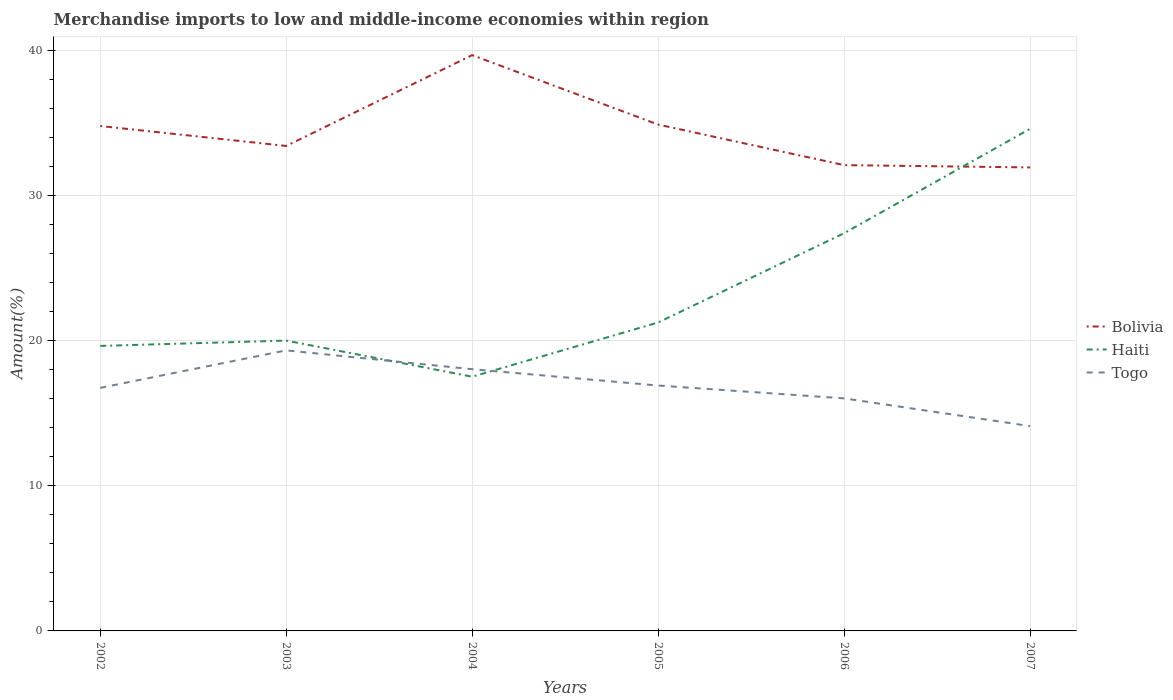How many different coloured lines are there?
Make the answer very short. 3. Across all years, what is the maximum percentage of amount earned from merchandise imports in Bolivia?
Your answer should be very brief. 31.94. In which year was the percentage of amount earned from merchandise imports in Togo maximum?
Your answer should be very brief. 2007. What is the total percentage of amount earned from merchandise imports in Haiti in the graph?
Offer a very short reply. -6.15. What is the difference between the highest and the second highest percentage of amount earned from merchandise imports in Togo?
Offer a terse response. 5.22. How many lines are there?
Your answer should be very brief. 3. Does the graph contain any zero values?
Offer a very short reply. No. Does the graph contain grids?
Give a very brief answer. Yes. Where does the legend appear in the graph?
Provide a succinct answer. Center right. How many legend labels are there?
Keep it short and to the point. 3. What is the title of the graph?
Offer a terse response. Merchandise imports to low and middle-income economies within region. Does "Croatia" appear as one of the legend labels in the graph?
Ensure brevity in your answer.  No. What is the label or title of the Y-axis?
Your answer should be very brief. Amount(%). What is the Amount(%) of Bolivia in 2002?
Ensure brevity in your answer.  34.79. What is the Amount(%) in Haiti in 2002?
Your answer should be compact. 19.64. What is the Amount(%) in Togo in 2002?
Make the answer very short. 16.75. What is the Amount(%) in Bolivia in 2003?
Offer a terse response. 33.42. What is the Amount(%) in Haiti in 2003?
Offer a very short reply. 20. What is the Amount(%) of Togo in 2003?
Offer a very short reply. 19.33. What is the Amount(%) of Bolivia in 2004?
Your response must be concise. 39.67. What is the Amount(%) of Haiti in 2004?
Give a very brief answer. 17.52. What is the Amount(%) of Togo in 2004?
Ensure brevity in your answer.  18.03. What is the Amount(%) of Bolivia in 2005?
Your answer should be very brief. 34.89. What is the Amount(%) of Haiti in 2005?
Provide a short and direct response. 21.25. What is the Amount(%) of Togo in 2005?
Offer a terse response. 16.91. What is the Amount(%) of Bolivia in 2006?
Provide a short and direct response. 32.09. What is the Amount(%) in Haiti in 2006?
Keep it short and to the point. 27.41. What is the Amount(%) of Togo in 2006?
Keep it short and to the point. 16.02. What is the Amount(%) of Bolivia in 2007?
Your response must be concise. 31.94. What is the Amount(%) of Haiti in 2007?
Offer a terse response. 34.6. What is the Amount(%) in Togo in 2007?
Your response must be concise. 14.11. Across all years, what is the maximum Amount(%) in Bolivia?
Provide a succinct answer. 39.67. Across all years, what is the maximum Amount(%) of Haiti?
Keep it short and to the point. 34.6. Across all years, what is the maximum Amount(%) in Togo?
Provide a short and direct response. 19.33. Across all years, what is the minimum Amount(%) of Bolivia?
Keep it short and to the point. 31.94. Across all years, what is the minimum Amount(%) in Haiti?
Provide a short and direct response. 17.52. Across all years, what is the minimum Amount(%) of Togo?
Your answer should be compact. 14.11. What is the total Amount(%) in Bolivia in the graph?
Give a very brief answer. 206.8. What is the total Amount(%) of Haiti in the graph?
Your answer should be compact. 140.42. What is the total Amount(%) in Togo in the graph?
Your answer should be compact. 101.15. What is the difference between the Amount(%) of Bolivia in 2002 and that in 2003?
Make the answer very short. 1.37. What is the difference between the Amount(%) in Haiti in 2002 and that in 2003?
Offer a very short reply. -0.37. What is the difference between the Amount(%) of Togo in 2002 and that in 2003?
Give a very brief answer. -2.58. What is the difference between the Amount(%) in Bolivia in 2002 and that in 2004?
Offer a terse response. -4.88. What is the difference between the Amount(%) of Haiti in 2002 and that in 2004?
Keep it short and to the point. 2.12. What is the difference between the Amount(%) in Togo in 2002 and that in 2004?
Give a very brief answer. -1.29. What is the difference between the Amount(%) in Bolivia in 2002 and that in 2005?
Your answer should be very brief. -0.1. What is the difference between the Amount(%) in Haiti in 2002 and that in 2005?
Offer a terse response. -1.62. What is the difference between the Amount(%) of Togo in 2002 and that in 2005?
Offer a very short reply. -0.16. What is the difference between the Amount(%) in Bolivia in 2002 and that in 2006?
Provide a short and direct response. 2.7. What is the difference between the Amount(%) in Haiti in 2002 and that in 2006?
Provide a succinct answer. -7.77. What is the difference between the Amount(%) of Togo in 2002 and that in 2006?
Offer a very short reply. 0.72. What is the difference between the Amount(%) in Bolivia in 2002 and that in 2007?
Your answer should be very brief. 2.85. What is the difference between the Amount(%) in Haiti in 2002 and that in 2007?
Offer a terse response. -14.96. What is the difference between the Amount(%) of Togo in 2002 and that in 2007?
Provide a short and direct response. 2.63. What is the difference between the Amount(%) in Bolivia in 2003 and that in 2004?
Provide a succinct answer. -6.26. What is the difference between the Amount(%) of Haiti in 2003 and that in 2004?
Offer a terse response. 2.49. What is the difference between the Amount(%) in Togo in 2003 and that in 2004?
Keep it short and to the point. 1.3. What is the difference between the Amount(%) of Bolivia in 2003 and that in 2005?
Offer a terse response. -1.47. What is the difference between the Amount(%) of Haiti in 2003 and that in 2005?
Offer a terse response. -1.25. What is the difference between the Amount(%) in Togo in 2003 and that in 2005?
Make the answer very short. 2.42. What is the difference between the Amount(%) in Bolivia in 2003 and that in 2006?
Provide a short and direct response. 1.32. What is the difference between the Amount(%) of Haiti in 2003 and that in 2006?
Make the answer very short. -7.4. What is the difference between the Amount(%) in Togo in 2003 and that in 2006?
Offer a very short reply. 3.31. What is the difference between the Amount(%) of Bolivia in 2003 and that in 2007?
Ensure brevity in your answer.  1.48. What is the difference between the Amount(%) of Haiti in 2003 and that in 2007?
Provide a short and direct response. -14.6. What is the difference between the Amount(%) of Togo in 2003 and that in 2007?
Ensure brevity in your answer.  5.22. What is the difference between the Amount(%) of Bolivia in 2004 and that in 2005?
Offer a very short reply. 4.79. What is the difference between the Amount(%) in Haiti in 2004 and that in 2005?
Your answer should be very brief. -3.74. What is the difference between the Amount(%) of Togo in 2004 and that in 2005?
Ensure brevity in your answer.  1.12. What is the difference between the Amount(%) of Bolivia in 2004 and that in 2006?
Your answer should be very brief. 7.58. What is the difference between the Amount(%) in Haiti in 2004 and that in 2006?
Make the answer very short. -9.89. What is the difference between the Amount(%) of Togo in 2004 and that in 2006?
Your answer should be compact. 2.01. What is the difference between the Amount(%) in Bolivia in 2004 and that in 2007?
Keep it short and to the point. 7.74. What is the difference between the Amount(%) of Haiti in 2004 and that in 2007?
Give a very brief answer. -17.08. What is the difference between the Amount(%) of Togo in 2004 and that in 2007?
Your response must be concise. 3.92. What is the difference between the Amount(%) of Bolivia in 2005 and that in 2006?
Provide a short and direct response. 2.79. What is the difference between the Amount(%) of Haiti in 2005 and that in 2006?
Provide a succinct answer. -6.15. What is the difference between the Amount(%) of Togo in 2005 and that in 2006?
Offer a very short reply. 0.89. What is the difference between the Amount(%) in Bolivia in 2005 and that in 2007?
Provide a short and direct response. 2.95. What is the difference between the Amount(%) in Haiti in 2005 and that in 2007?
Provide a succinct answer. -13.35. What is the difference between the Amount(%) in Togo in 2005 and that in 2007?
Your response must be concise. 2.79. What is the difference between the Amount(%) of Bolivia in 2006 and that in 2007?
Your answer should be compact. 0.16. What is the difference between the Amount(%) in Haiti in 2006 and that in 2007?
Offer a terse response. -7.19. What is the difference between the Amount(%) in Togo in 2006 and that in 2007?
Give a very brief answer. 1.91. What is the difference between the Amount(%) of Bolivia in 2002 and the Amount(%) of Haiti in 2003?
Provide a succinct answer. 14.79. What is the difference between the Amount(%) of Bolivia in 2002 and the Amount(%) of Togo in 2003?
Your answer should be compact. 15.46. What is the difference between the Amount(%) in Haiti in 2002 and the Amount(%) in Togo in 2003?
Make the answer very short. 0.31. What is the difference between the Amount(%) in Bolivia in 2002 and the Amount(%) in Haiti in 2004?
Give a very brief answer. 17.27. What is the difference between the Amount(%) of Bolivia in 2002 and the Amount(%) of Togo in 2004?
Give a very brief answer. 16.76. What is the difference between the Amount(%) in Haiti in 2002 and the Amount(%) in Togo in 2004?
Provide a short and direct response. 1.6. What is the difference between the Amount(%) in Bolivia in 2002 and the Amount(%) in Haiti in 2005?
Provide a short and direct response. 13.54. What is the difference between the Amount(%) in Bolivia in 2002 and the Amount(%) in Togo in 2005?
Your answer should be very brief. 17.88. What is the difference between the Amount(%) of Haiti in 2002 and the Amount(%) of Togo in 2005?
Your answer should be compact. 2.73. What is the difference between the Amount(%) in Bolivia in 2002 and the Amount(%) in Haiti in 2006?
Offer a terse response. 7.38. What is the difference between the Amount(%) in Bolivia in 2002 and the Amount(%) in Togo in 2006?
Give a very brief answer. 18.77. What is the difference between the Amount(%) in Haiti in 2002 and the Amount(%) in Togo in 2006?
Your answer should be compact. 3.61. What is the difference between the Amount(%) in Bolivia in 2002 and the Amount(%) in Haiti in 2007?
Your answer should be compact. 0.19. What is the difference between the Amount(%) in Bolivia in 2002 and the Amount(%) in Togo in 2007?
Your response must be concise. 20.68. What is the difference between the Amount(%) of Haiti in 2002 and the Amount(%) of Togo in 2007?
Your answer should be very brief. 5.52. What is the difference between the Amount(%) of Bolivia in 2003 and the Amount(%) of Haiti in 2004?
Your response must be concise. 15.9. What is the difference between the Amount(%) in Bolivia in 2003 and the Amount(%) in Togo in 2004?
Offer a terse response. 15.38. What is the difference between the Amount(%) in Haiti in 2003 and the Amount(%) in Togo in 2004?
Make the answer very short. 1.97. What is the difference between the Amount(%) of Bolivia in 2003 and the Amount(%) of Haiti in 2005?
Keep it short and to the point. 12.16. What is the difference between the Amount(%) in Bolivia in 2003 and the Amount(%) in Togo in 2005?
Make the answer very short. 16.51. What is the difference between the Amount(%) in Haiti in 2003 and the Amount(%) in Togo in 2005?
Your answer should be compact. 3.1. What is the difference between the Amount(%) in Bolivia in 2003 and the Amount(%) in Haiti in 2006?
Provide a succinct answer. 6.01. What is the difference between the Amount(%) of Bolivia in 2003 and the Amount(%) of Togo in 2006?
Offer a terse response. 17.39. What is the difference between the Amount(%) of Haiti in 2003 and the Amount(%) of Togo in 2006?
Provide a succinct answer. 3.98. What is the difference between the Amount(%) of Bolivia in 2003 and the Amount(%) of Haiti in 2007?
Ensure brevity in your answer.  -1.18. What is the difference between the Amount(%) of Bolivia in 2003 and the Amount(%) of Togo in 2007?
Your answer should be compact. 19.3. What is the difference between the Amount(%) of Haiti in 2003 and the Amount(%) of Togo in 2007?
Offer a terse response. 5.89. What is the difference between the Amount(%) in Bolivia in 2004 and the Amount(%) in Haiti in 2005?
Your answer should be very brief. 18.42. What is the difference between the Amount(%) of Bolivia in 2004 and the Amount(%) of Togo in 2005?
Provide a succinct answer. 22.77. What is the difference between the Amount(%) in Haiti in 2004 and the Amount(%) in Togo in 2005?
Offer a terse response. 0.61. What is the difference between the Amount(%) of Bolivia in 2004 and the Amount(%) of Haiti in 2006?
Offer a very short reply. 12.27. What is the difference between the Amount(%) of Bolivia in 2004 and the Amount(%) of Togo in 2006?
Provide a succinct answer. 23.65. What is the difference between the Amount(%) in Haiti in 2004 and the Amount(%) in Togo in 2006?
Keep it short and to the point. 1.49. What is the difference between the Amount(%) of Bolivia in 2004 and the Amount(%) of Haiti in 2007?
Your answer should be very brief. 5.07. What is the difference between the Amount(%) of Bolivia in 2004 and the Amount(%) of Togo in 2007?
Make the answer very short. 25.56. What is the difference between the Amount(%) in Haiti in 2004 and the Amount(%) in Togo in 2007?
Keep it short and to the point. 3.4. What is the difference between the Amount(%) in Bolivia in 2005 and the Amount(%) in Haiti in 2006?
Your answer should be compact. 7.48. What is the difference between the Amount(%) in Bolivia in 2005 and the Amount(%) in Togo in 2006?
Make the answer very short. 18.86. What is the difference between the Amount(%) of Haiti in 2005 and the Amount(%) of Togo in 2006?
Your answer should be very brief. 5.23. What is the difference between the Amount(%) in Bolivia in 2005 and the Amount(%) in Haiti in 2007?
Keep it short and to the point. 0.29. What is the difference between the Amount(%) in Bolivia in 2005 and the Amount(%) in Togo in 2007?
Your answer should be compact. 20.77. What is the difference between the Amount(%) in Haiti in 2005 and the Amount(%) in Togo in 2007?
Offer a terse response. 7.14. What is the difference between the Amount(%) in Bolivia in 2006 and the Amount(%) in Haiti in 2007?
Your answer should be very brief. -2.51. What is the difference between the Amount(%) in Bolivia in 2006 and the Amount(%) in Togo in 2007?
Your answer should be very brief. 17.98. What is the difference between the Amount(%) in Haiti in 2006 and the Amount(%) in Togo in 2007?
Ensure brevity in your answer.  13.29. What is the average Amount(%) of Bolivia per year?
Your response must be concise. 34.47. What is the average Amount(%) in Haiti per year?
Give a very brief answer. 23.4. What is the average Amount(%) in Togo per year?
Offer a terse response. 16.86. In the year 2002, what is the difference between the Amount(%) in Bolivia and Amount(%) in Haiti?
Offer a terse response. 15.15. In the year 2002, what is the difference between the Amount(%) in Bolivia and Amount(%) in Togo?
Keep it short and to the point. 18.04. In the year 2002, what is the difference between the Amount(%) of Haiti and Amount(%) of Togo?
Give a very brief answer. 2.89. In the year 2003, what is the difference between the Amount(%) in Bolivia and Amount(%) in Haiti?
Offer a terse response. 13.41. In the year 2003, what is the difference between the Amount(%) of Bolivia and Amount(%) of Togo?
Ensure brevity in your answer.  14.08. In the year 2003, what is the difference between the Amount(%) in Haiti and Amount(%) in Togo?
Ensure brevity in your answer.  0.67. In the year 2004, what is the difference between the Amount(%) of Bolivia and Amount(%) of Haiti?
Offer a terse response. 22.16. In the year 2004, what is the difference between the Amount(%) of Bolivia and Amount(%) of Togo?
Provide a succinct answer. 21.64. In the year 2004, what is the difference between the Amount(%) of Haiti and Amount(%) of Togo?
Your response must be concise. -0.52. In the year 2005, what is the difference between the Amount(%) in Bolivia and Amount(%) in Haiti?
Make the answer very short. 13.64. In the year 2005, what is the difference between the Amount(%) of Bolivia and Amount(%) of Togo?
Give a very brief answer. 17.98. In the year 2005, what is the difference between the Amount(%) in Haiti and Amount(%) in Togo?
Offer a terse response. 4.34. In the year 2006, what is the difference between the Amount(%) of Bolivia and Amount(%) of Haiti?
Keep it short and to the point. 4.69. In the year 2006, what is the difference between the Amount(%) of Bolivia and Amount(%) of Togo?
Make the answer very short. 16.07. In the year 2006, what is the difference between the Amount(%) in Haiti and Amount(%) in Togo?
Offer a terse response. 11.38. In the year 2007, what is the difference between the Amount(%) of Bolivia and Amount(%) of Haiti?
Your response must be concise. -2.67. In the year 2007, what is the difference between the Amount(%) in Bolivia and Amount(%) in Togo?
Provide a succinct answer. 17.82. In the year 2007, what is the difference between the Amount(%) in Haiti and Amount(%) in Togo?
Provide a short and direct response. 20.49. What is the ratio of the Amount(%) of Bolivia in 2002 to that in 2003?
Offer a very short reply. 1.04. What is the ratio of the Amount(%) in Haiti in 2002 to that in 2003?
Your response must be concise. 0.98. What is the ratio of the Amount(%) in Togo in 2002 to that in 2003?
Make the answer very short. 0.87. What is the ratio of the Amount(%) of Bolivia in 2002 to that in 2004?
Keep it short and to the point. 0.88. What is the ratio of the Amount(%) in Haiti in 2002 to that in 2004?
Your response must be concise. 1.12. What is the ratio of the Amount(%) of Togo in 2002 to that in 2004?
Keep it short and to the point. 0.93. What is the ratio of the Amount(%) in Bolivia in 2002 to that in 2005?
Offer a terse response. 1. What is the ratio of the Amount(%) of Haiti in 2002 to that in 2005?
Your response must be concise. 0.92. What is the ratio of the Amount(%) in Bolivia in 2002 to that in 2006?
Ensure brevity in your answer.  1.08. What is the ratio of the Amount(%) of Haiti in 2002 to that in 2006?
Keep it short and to the point. 0.72. What is the ratio of the Amount(%) in Togo in 2002 to that in 2006?
Offer a terse response. 1.05. What is the ratio of the Amount(%) of Bolivia in 2002 to that in 2007?
Provide a succinct answer. 1.09. What is the ratio of the Amount(%) of Haiti in 2002 to that in 2007?
Provide a short and direct response. 0.57. What is the ratio of the Amount(%) in Togo in 2002 to that in 2007?
Your response must be concise. 1.19. What is the ratio of the Amount(%) of Bolivia in 2003 to that in 2004?
Your answer should be compact. 0.84. What is the ratio of the Amount(%) of Haiti in 2003 to that in 2004?
Provide a succinct answer. 1.14. What is the ratio of the Amount(%) of Togo in 2003 to that in 2004?
Keep it short and to the point. 1.07. What is the ratio of the Amount(%) of Bolivia in 2003 to that in 2005?
Give a very brief answer. 0.96. What is the ratio of the Amount(%) of Haiti in 2003 to that in 2005?
Your answer should be very brief. 0.94. What is the ratio of the Amount(%) in Togo in 2003 to that in 2005?
Keep it short and to the point. 1.14. What is the ratio of the Amount(%) of Bolivia in 2003 to that in 2006?
Provide a short and direct response. 1.04. What is the ratio of the Amount(%) in Haiti in 2003 to that in 2006?
Ensure brevity in your answer.  0.73. What is the ratio of the Amount(%) in Togo in 2003 to that in 2006?
Provide a succinct answer. 1.21. What is the ratio of the Amount(%) of Bolivia in 2003 to that in 2007?
Provide a succinct answer. 1.05. What is the ratio of the Amount(%) of Haiti in 2003 to that in 2007?
Ensure brevity in your answer.  0.58. What is the ratio of the Amount(%) in Togo in 2003 to that in 2007?
Ensure brevity in your answer.  1.37. What is the ratio of the Amount(%) in Bolivia in 2004 to that in 2005?
Ensure brevity in your answer.  1.14. What is the ratio of the Amount(%) of Haiti in 2004 to that in 2005?
Your answer should be very brief. 0.82. What is the ratio of the Amount(%) of Togo in 2004 to that in 2005?
Offer a terse response. 1.07. What is the ratio of the Amount(%) of Bolivia in 2004 to that in 2006?
Offer a very short reply. 1.24. What is the ratio of the Amount(%) in Haiti in 2004 to that in 2006?
Give a very brief answer. 0.64. What is the ratio of the Amount(%) of Togo in 2004 to that in 2006?
Your answer should be very brief. 1.13. What is the ratio of the Amount(%) of Bolivia in 2004 to that in 2007?
Offer a very short reply. 1.24. What is the ratio of the Amount(%) of Haiti in 2004 to that in 2007?
Offer a terse response. 0.51. What is the ratio of the Amount(%) in Togo in 2004 to that in 2007?
Offer a very short reply. 1.28. What is the ratio of the Amount(%) of Bolivia in 2005 to that in 2006?
Your answer should be very brief. 1.09. What is the ratio of the Amount(%) of Haiti in 2005 to that in 2006?
Ensure brevity in your answer.  0.78. What is the ratio of the Amount(%) of Togo in 2005 to that in 2006?
Make the answer very short. 1.06. What is the ratio of the Amount(%) in Bolivia in 2005 to that in 2007?
Make the answer very short. 1.09. What is the ratio of the Amount(%) of Haiti in 2005 to that in 2007?
Ensure brevity in your answer.  0.61. What is the ratio of the Amount(%) in Togo in 2005 to that in 2007?
Your answer should be very brief. 1.2. What is the ratio of the Amount(%) of Bolivia in 2006 to that in 2007?
Offer a very short reply. 1. What is the ratio of the Amount(%) of Haiti in 2006 to that in 2007?
Ensure brevity in your answer.  0.79. What is the ratio of the Amount(%) of Togo in 2006 to that in 2007?
Your answer should be very brief. 1.14. What is the difference between the highest and the second highest Amount(%) of Bolivia?
Offer a very short reply. 4.79. What is the difference between the highest and the second highest Amount(%) of Haiti?
Offer a very short reply. 7.19. What is the difference between the highest and the second highest Amount(%) in Togo?
Offer a very short reply. 1.3. What is the difference between the highest and the lowest Amount(%) in Bolivia?
Offer a terse response. 7.74. What is the difference between the highest and the lowest Amount(%) in Haiti?
Keep it short and to the point. 17.08. What is the difference between the highest and the lowest Amount(%) of Togo?
Give a very brief answer. 5.22. 